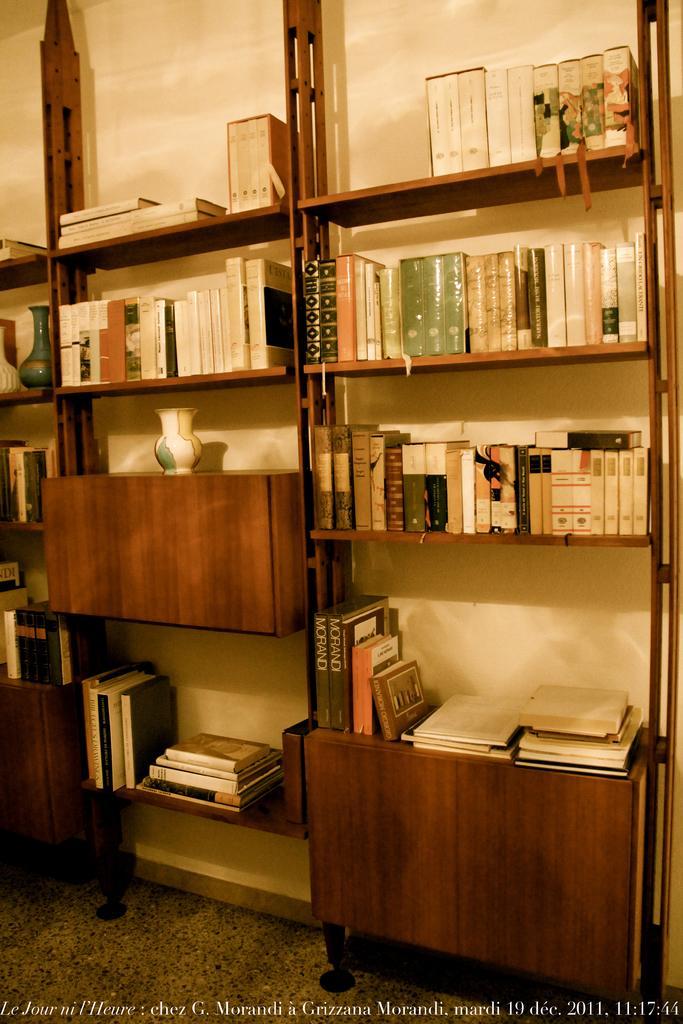Describe this image in one or two sentences. In this image I can see number of books on the shelves. On this left side of this image I can see few vases and on the bottom side I can see something is written. 